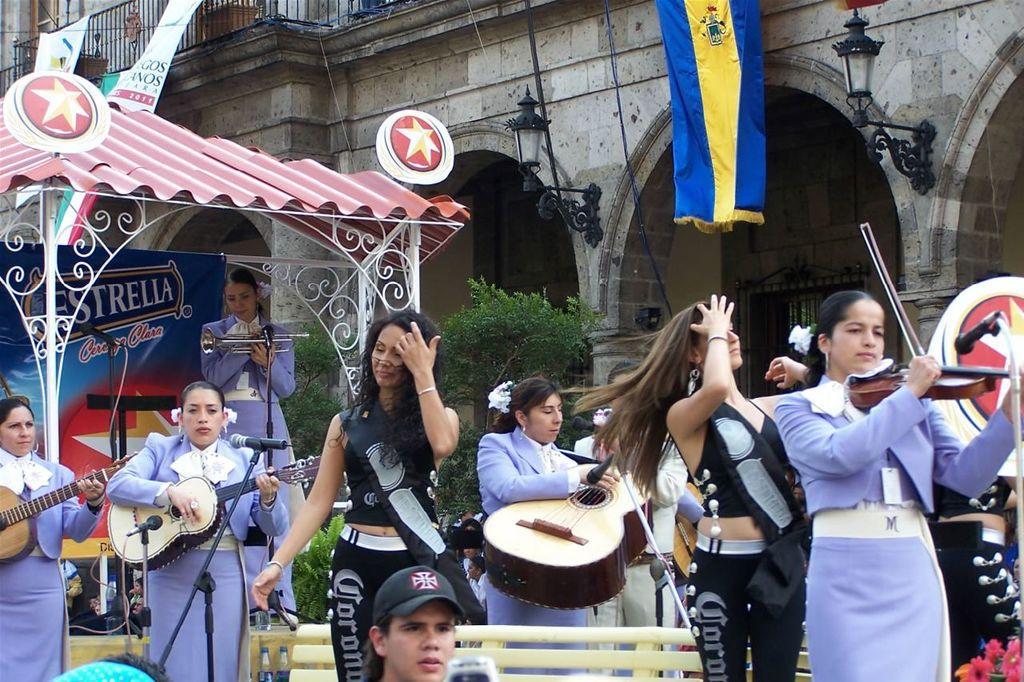Describe this image in one or two sentences. On the background of the picture we can see one building. This is a flag. These are lights. Here we can see a platform where one women is standing and playing a musical instrument. In Front of the picture we can see few persons standing and playing a musical instruments. Here we can see a man wearing a cap. This is a flower at the right side of the picture. This is a plant. 